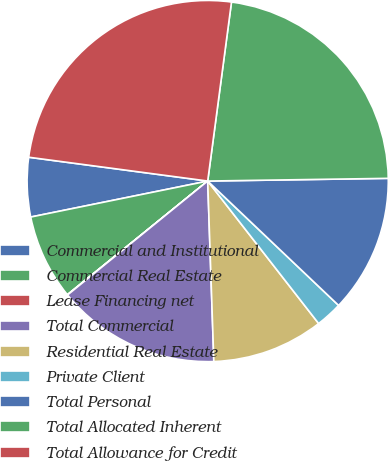Convert chart. <chart><loc_0><loc_0><loc_500><loc_500><pie_chart><fcel>Commercial and Institutional<fcel>Commercial Real Estate<fcel>Lease Financing net<fcel>Total Commercial<fcel>Residential Real Estate<fcel>Private Client<fcel>Total Personal<fcel>Total Allocated Inherent<fcel>Total Allowance for Credit<nl><fcel>5.3%<fcel>7.64%<fcel>0.03%<fcel>14.68%<fcel>9.99%<fcel>2.38%<fcel>12.33%<fcel>22.66%<fcel>25.0%<nl></chart> 